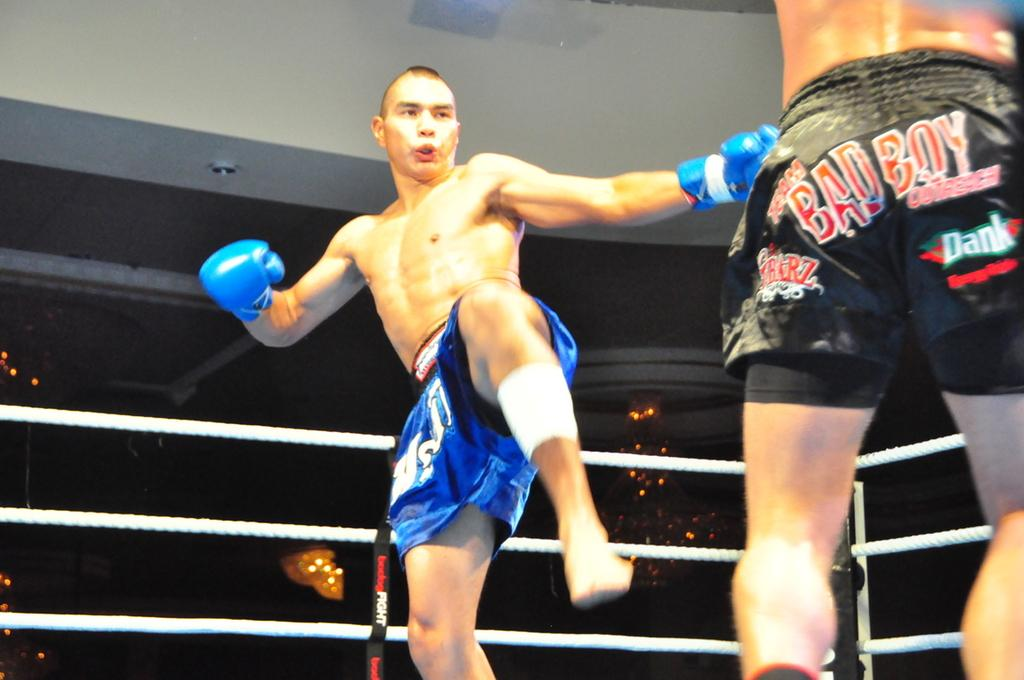Provide a one-sentence caption for the provided image. A kickboxer in blue shorts aims a kick at his opponent who is wearing black shorts with BAD BOY written on them as well as sponsors names. 